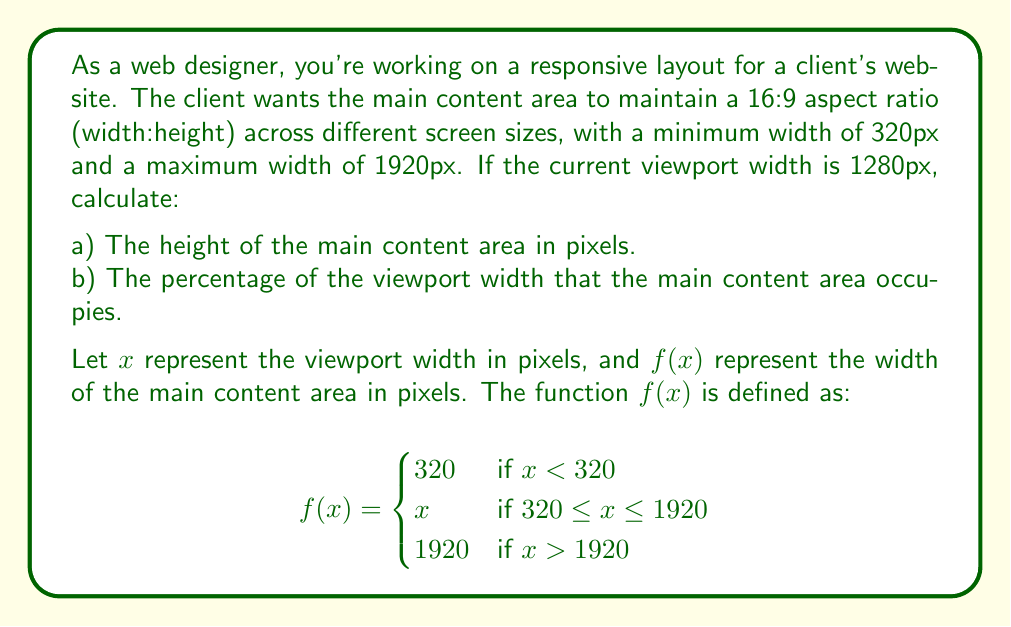Solve this math problem. To solve this problem, we'll follow these steps:

1. Determine the width of the main content area using the given function $f(x)$.
2. Calculate the height of the main content area using the 16:9 aspect ratio.
3. Calculate the percentage of the viewport width occupied by the main content area.

Step 1: Determine the width of the main content area
The current viewport width is 1280px. Since $320 \leq 1280 \leq 1920$, we use the middle case of the piecewise function:

$f(1280) = 1280$

So, the width of the main content area is 1280px.

Step 2: Calculate the height of the main content area
To maintain a 16:9 aspect ratio, we use the formula:

$\text{height} = \frac{\text{width}}{16/9} = \frac{\text{width} \times 9}{16}$

Plugging in our width:

$\text{height} = \frac{1280 \times 9}{16} = 720\text{ px}$

Step 3: Calculate the percentage of viewport width
The main content area width is equal to the viewport width, so it occupies 100% of the viewport width.

Percentage = $\frac{\text{content width}}{\text{viewport width}} \times 100\% = \frac{1280}{1280} \times 100\% = 100\%$
Answer: a) The height of the main content area is 720 px.
b) The main content area occupies 100% of the viewport width. 